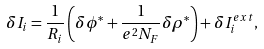Convert formula to latex. <formula><loc_0><loc_0><loc_500><loc_500>\delta I _ { i } = \frac { 1 } { R _ { i } } \left ( \delta \phi ^ { * } + \frac { 1 } { e ^ { 2 } N _ { F } } \delta \rho ^ { * } \right ) + \delta I _ { i } ^ { e x t } ,</formula> 